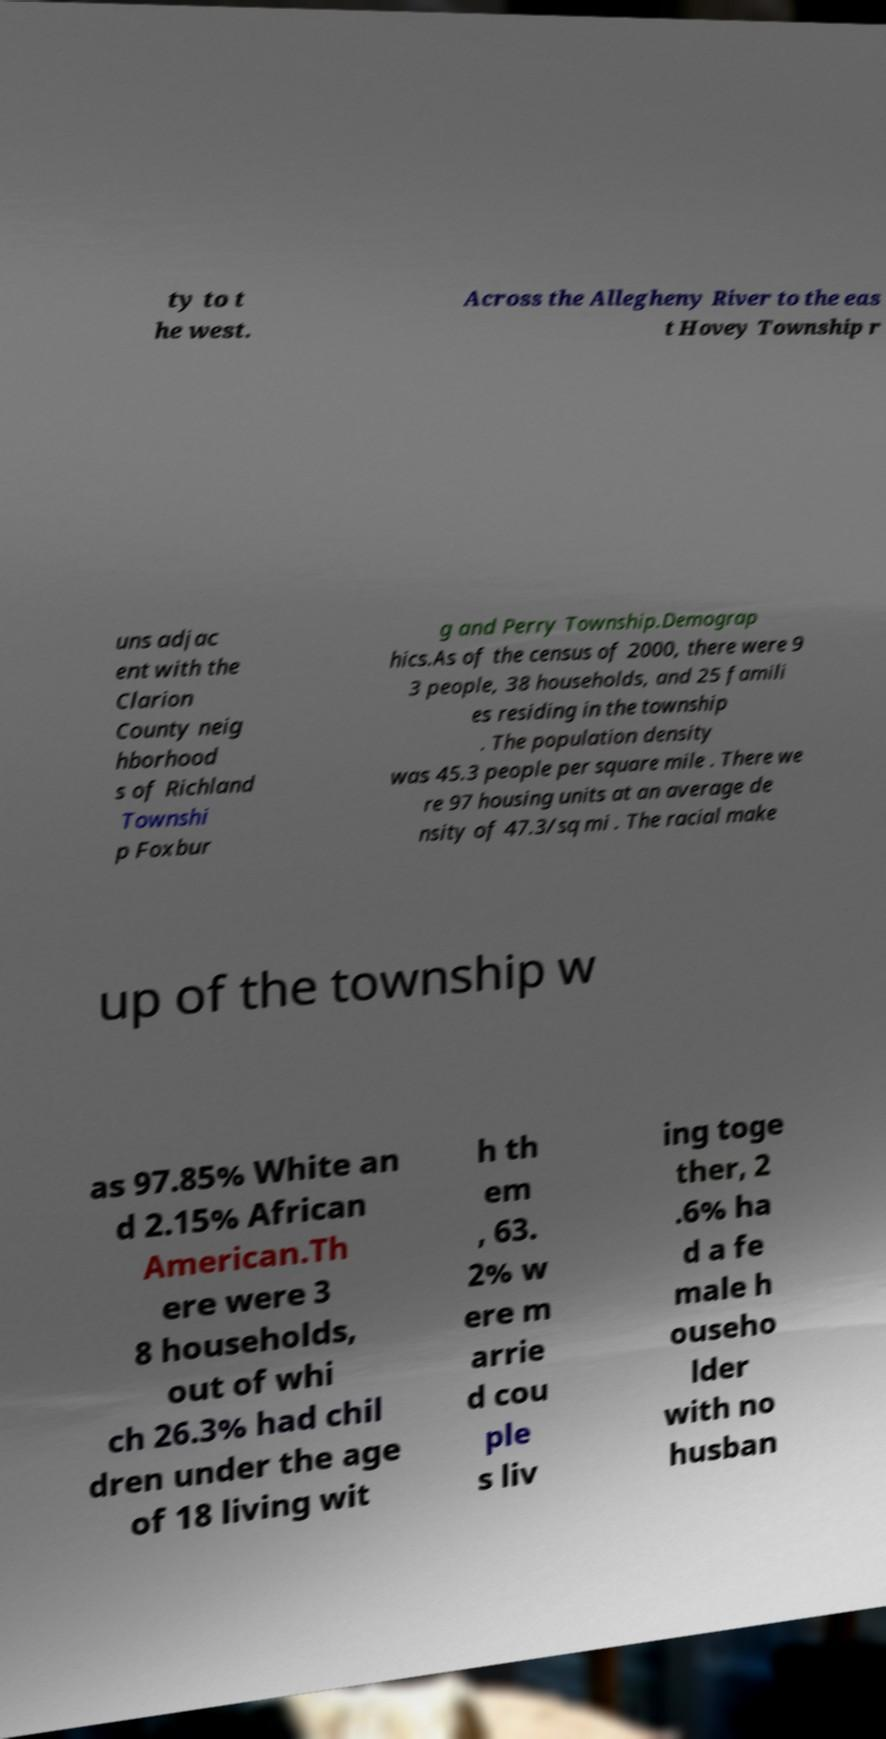For documentation purposes, I need the text within this image transcribed. Could you provide that? ty to t he west. Across the Allegheny River to the eas t Hovey Township r uns adjac ent with the Clarion County neig hborhood s of Richland Townshi p Foxbur g and Perry Township.Demograp hics.As of the census of 2000, there were 9 3 people, 38 households, and 25 famili es residing in the township . The population density was 45.3 people per square mile . There we re 97 housing units at an average de nsity of 47.3/sq mi . The racial make up of the township w as 97.85% White an d 2.15% African American.Th ere were 3 8 households, out of whi ch 26.3% had chil dren under the age of 18 living wit h th em , 63. 2% w ere m arrie d cou ple s liv ing toge ther, 2 .6% ha d a fe male h ouseho lder with no husban 